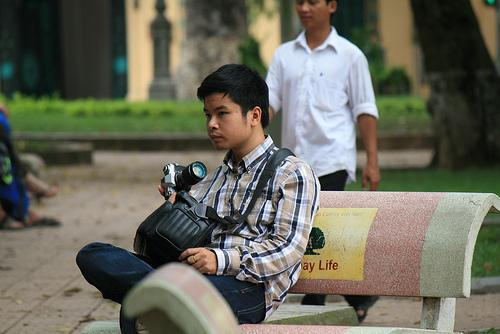Question: where was this photo taken?
Choices:
A. At the party.
B. In a park.
C. At the picnic.
D. At the concert.
Answer with the letter. Answer: B Question: what is the man carrying?
Choices:
A. A child.
B. A cat.
C. A drink.
D. A camera.
Answer with the letter. Answer: D Question: what is the man sitting on?
Choices:
A. A bench.
B. A chair.
C. A curb.
D. A stage.
Answer with the letter. Answer: B Question: who is behind the man sitting?
Choices:
A. A woman.
B. Another man.
C. A child.
D. A girl.
Answer with the letter. Answer: B 